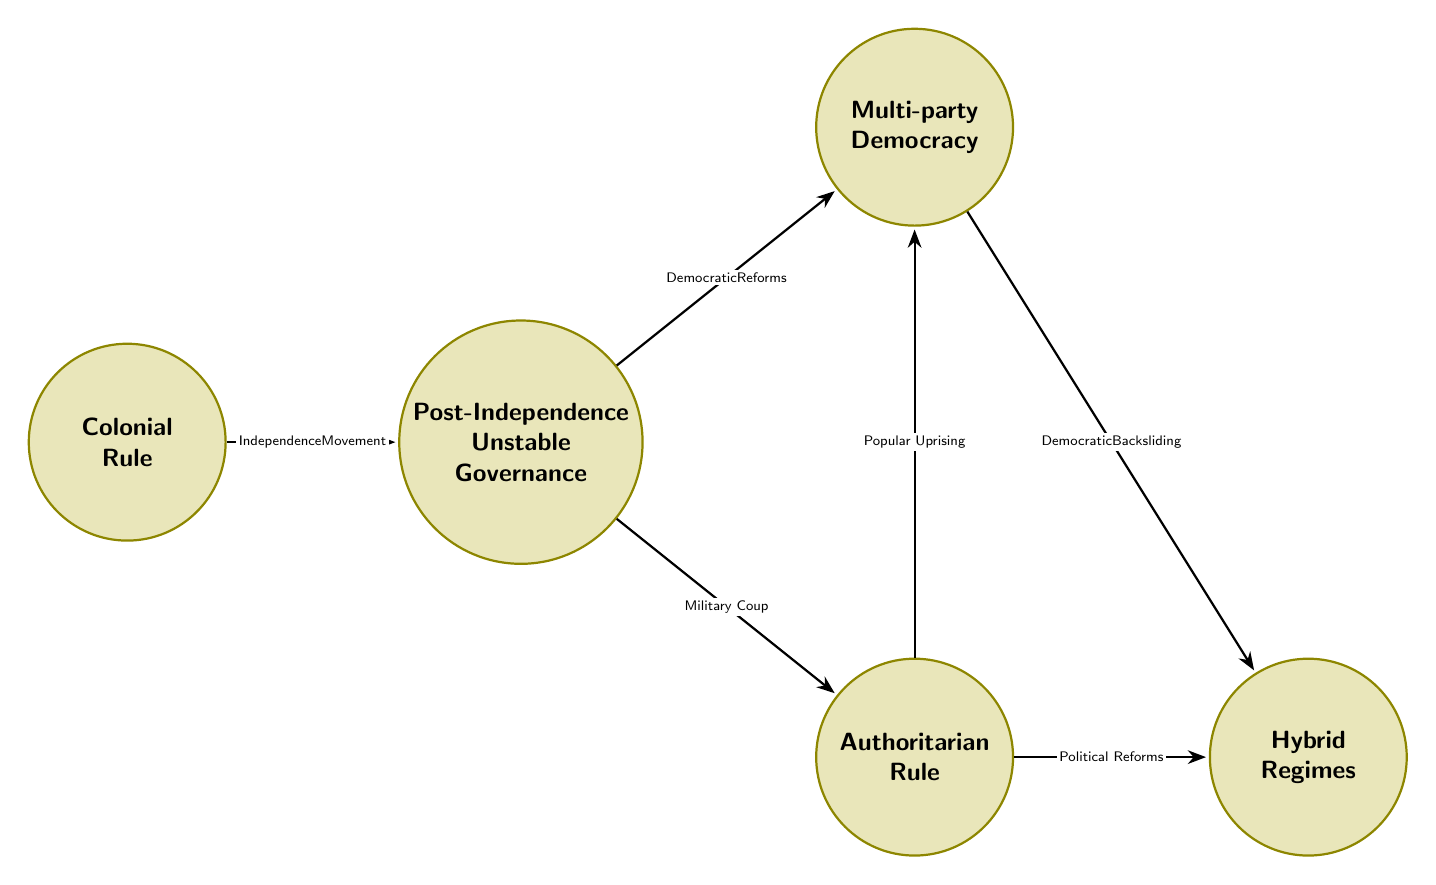What is the initial state in the diagram? The diagram starts with the state labeled "Colonial Rule," which represents the governance structure before independence.
Answer: Colonial Rule How many states are represented in the diagram? There are five distinct states shown in the diagram: Colonial Rule, Post-Independence Unstable Governance, Authoritarian Rule, Multi-party Democracy, and Hybrid Regimes.
Answer: 5 What transition leads from "Post-Independence Unstable Governance" to "Authoritarian Rule"? The transition from "Post-Independence Unstable Governance" to "Authoritarian Rule" is triggered by a "Military Coup," which indicates a shift in governance toward authoritarianism.
Answer: Military Coup What is the relationship between "Multi-party Democracy" and "Hybrid Regimes"? The relationship is characterized by a transition from "Multi-party Democracy" to "Hybrid Regimes," triggered by "Democratic Backsliding," suggesting a regression in democratic practices.
Answer: Democratic Backsliding Which state can be reached directly from "Post-Independence Unstable Governance"? From "Post-Independence Unstable Governance," one can transition either to "Authoritarian Rule" or to "Multi-party Democracy," indicating two possible paths stemming from the unstable governance phase.
Answer: Authoritarian Rule, Multi-party Democracy What triggers the transition from "Authoritarian Rule" to "Multi-party Democracy"? The trigger for this transition is a "Popular Uprising," where citizens protest against authoritarian rule leading to a move towards a democratic framework.
Answer: Popular Uprising Which transition connects "Colonial Rule" to another state? The transition from "Colonial Rule" to "Post-Independence Unstable Governance" is initiated by the "Independence Movement," reflecting the process of gaining independence from colonial powers.
Answer: Independence Movement What type of governance follows immediately after "Post-Independence Unstable Governance"? The type of governance that follows immediately after "Post-Independence Unstable Governance" can either be "Authoritarian Rule" or "Multi-party Democracy," based on the political developments occurring at that time.
Answer: Authoritarian Rule, Multi-party Democracy What is the state that may follow "Authoritarian Rule"? The state that may follow "Authoritarian Rule" is either "Hybrid Regimes" due to political reforms or "Multi-party Democracy" due to popular uprisings, reflecting both reform and revolutionary movements.
Answer: Hybrid Regimes, Multi-party Democracy 